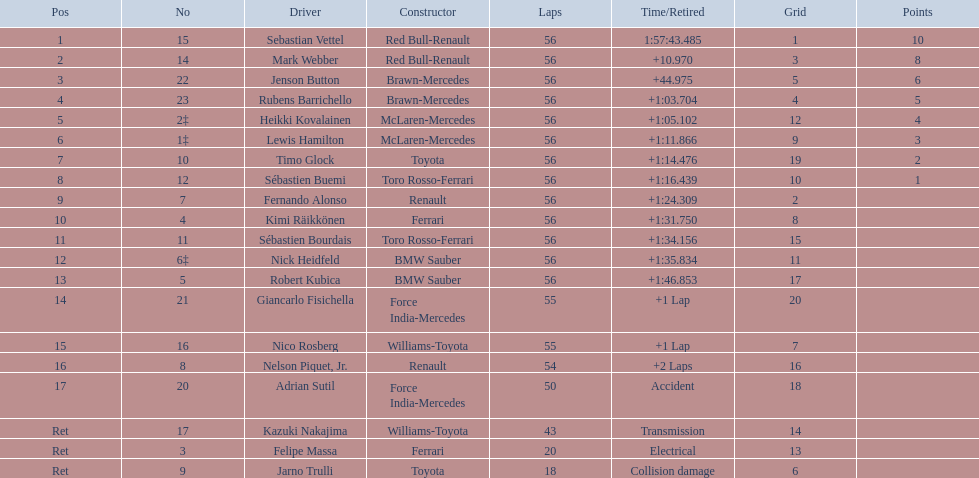Which driver's name is associated with a non-ferrari constructor? Sebastian Vettel. 